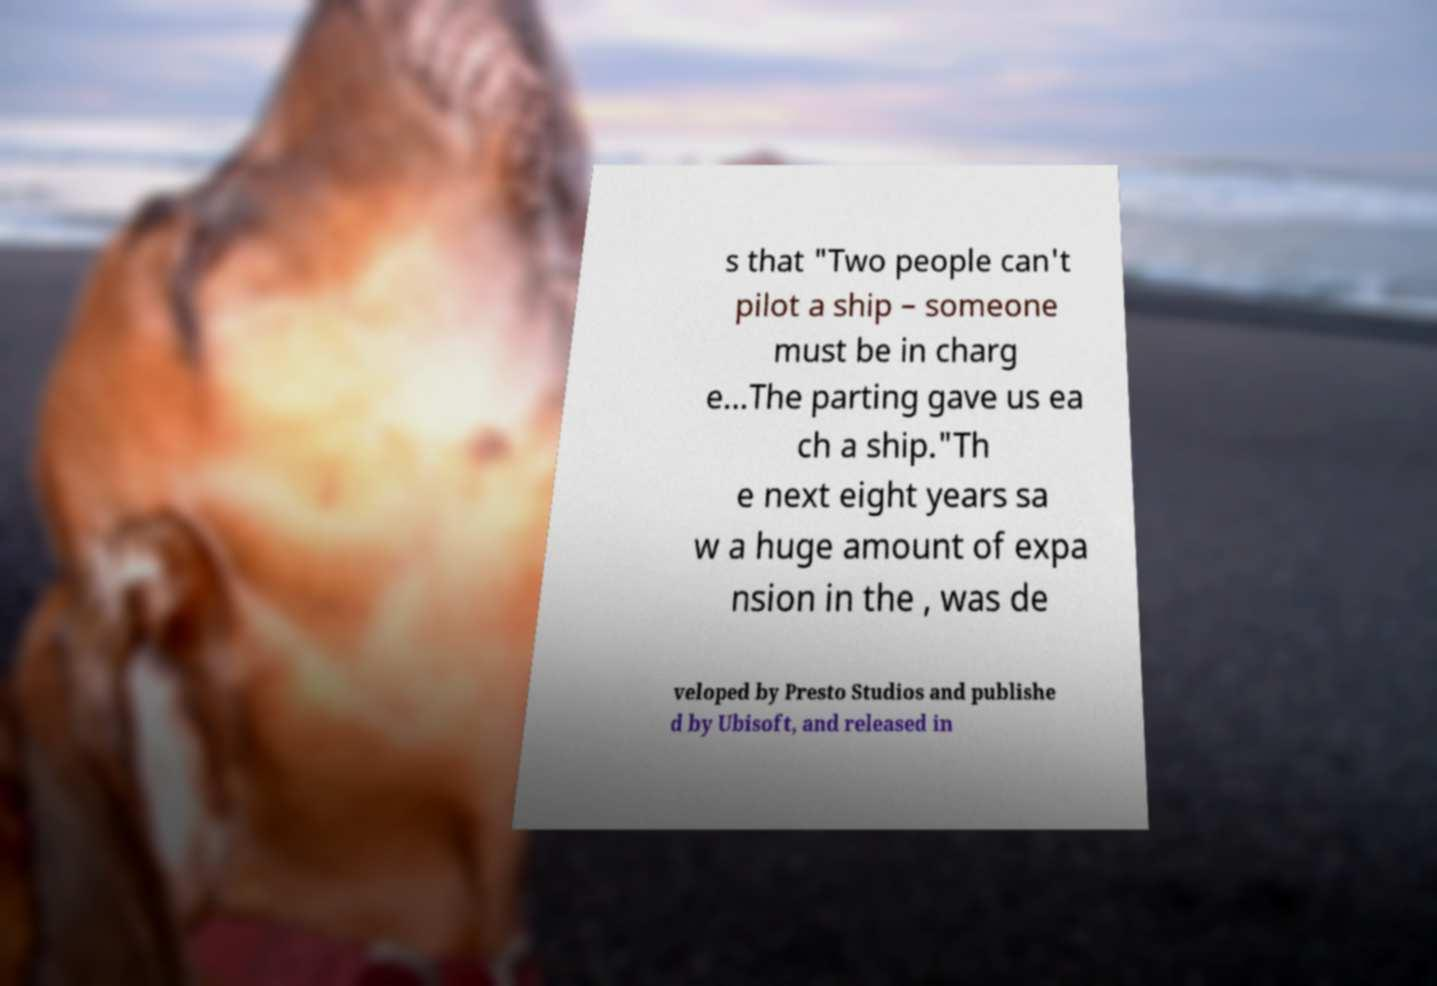Please read and relay the text visible in this image. What does it say? s that "Two people can't pilot a ship – someone must be in charg e...The parting gave us ea ch a ship."Th e next eight years sa w a huge amount of expa nsion in the , was de veloped by Presto Studios and publishe d by Ubisoft, and released in 